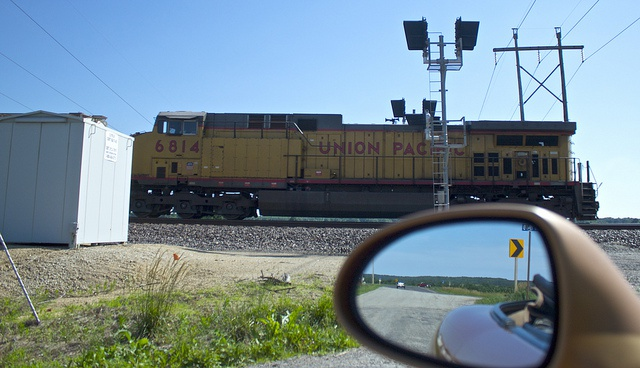Describe the objects in this image and their specific colors. I can see train in gray, black, and navy tones, car in gray, black, lightblue, and darkgray tones, traffic light in gray, navy, black, and blue tones, and traffic light in gray, navy, black, blue, and lightblue tones in this image. 